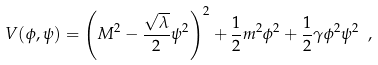<formula> <loc_0><loc_0><loc_500><loc_500>V ( \phi , \psi ) = \left ( M ^ { 2 } - \frac { \sqrt { \lambda } } { 2 } \psi ^ { 2 } \right ) ^ { 2 } + \frac { 1 } { 2 } m ^ { 2 } \phi ^ { 2 } + \frac { 1 } { 2 } \gamma \phi ^ { 2 } \psi ^ { 2 } \ ,</formula> 